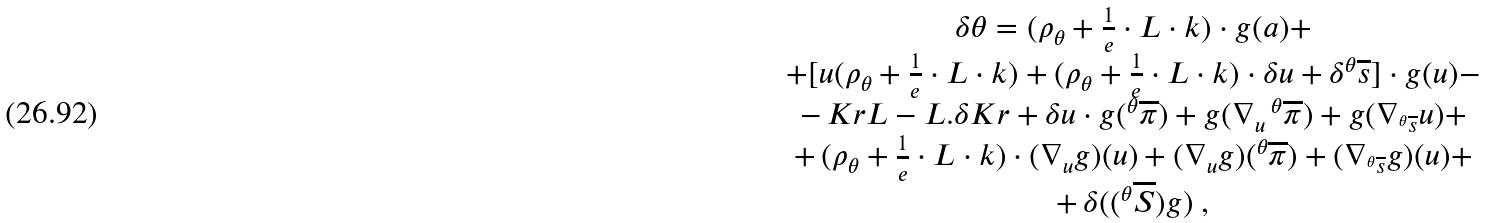Convert formula to latex. <formula><loc_0><loc_0><loc_500><loc_500>\begin{array} { c } \delta \theta = ( \rho _ { \theta } + \frac { 1 } { e } \cdot L \cdot k ) \cdot g ( a ) + \\ + [ u ( \rho _ { \theta } + \frac { 1 } { e } \cdot L \cdot k ) + ( \rho _ { \theta } + \frac { 1 } { e } \cdot L \cdot k ) \cdot \delta u + \delta ^ { \theta } \overline { s } ] \cdot g ( u ) - \\ - \, K r L - L . \delta K r + \delta u \cdot g ( ^ { \theta } \overline { \pi } ) + g ( \nabla _ { u } \, ^ { \theta } \overline { \pi } ) + g ( \nabla _ { ^ { \theta } \overline { s } } u ) + \\ + \, ( \rho _ { \theta } + \frac { 1 } { e } \cdot L \cdot k ) \cdot ( \nabla _ { u } g ) ( u ) + ( \nabla _ { u } g ) ( ^ { \theta } \overline { \pi } ) + ( \nabla _ { ^ { \theta } \overline { s } } g ) ( u ) + \\ + \, \delta ( ( ^ { \theta } \overline { S } ) g ) \text { ,} \end{array}</formula> 